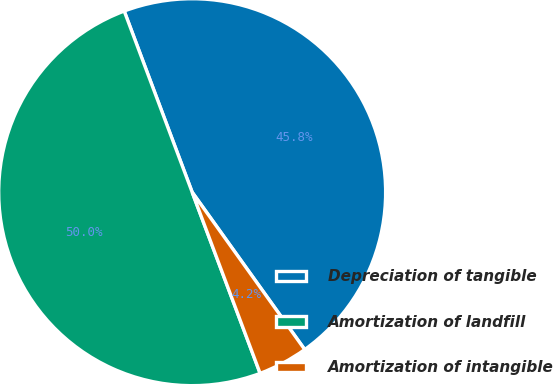<chart> <loc_0><loc_0><loc_500><loc_500><pie_chart><fcel>Depreciation of tangible<fcel>Amortization of landfill<fcel>Amortization of intangible<nl><fcel>45.83%<fcel>50.0%<fcel>4.17%<nl></chart> 